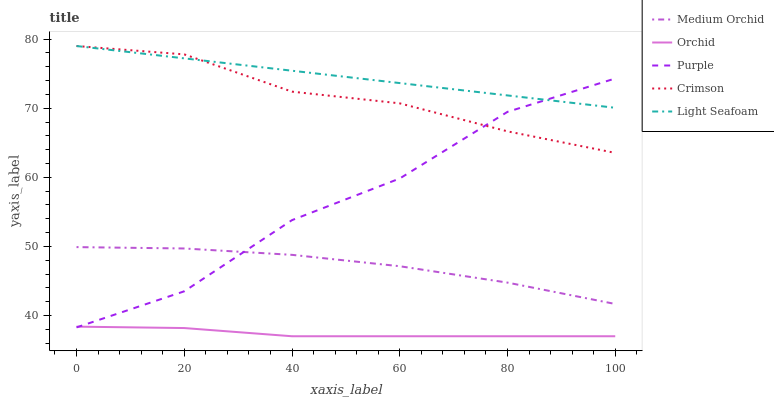Does Orchid have the minimum area under the curve?
Answer yes or no. Yes. Does Light Seafoam have the maximum area under the curve?
Answer yes or no. Yes. Does Crimson have the minimum area under the curve?
Answer yes or no. No. Does Crimson have the maximum area under the curve?
Answer yes or no. No. Is Light Seafoam the smoothest?
Answer yes or no. Yes. Is Purple the roughest?
Answer yes or no. Yes. Is Crimson the smoothest?
Answer yes or no. No. Is Crimson the roughest?
Answer yes or no. No. Does Orchid have the lowest value?
Answer yes or no. Yes. Does Crimson have the lowest value?
Answer yes or no. No. Does Light Seafoam have the highest value?
Answer yes or no. Yes. Does Medium Orchid have the highest value?
Answer yes or no. No. Is Medium Orchid less than Light Seafoam?
Answer yes or no. Yes. Is Crimson greater than Medium Orchid?
Answer yes or no. Yes. Does Crimson intersect Purple?
Answer yes or no. Yes. Is Crimson less than Purple?
Answer yes or no. No. Is Crimson greater than Purple?
Answer yes or no. No. Does Medium Orchid intersect Light Seafoam?
Answer yes or no. No. 